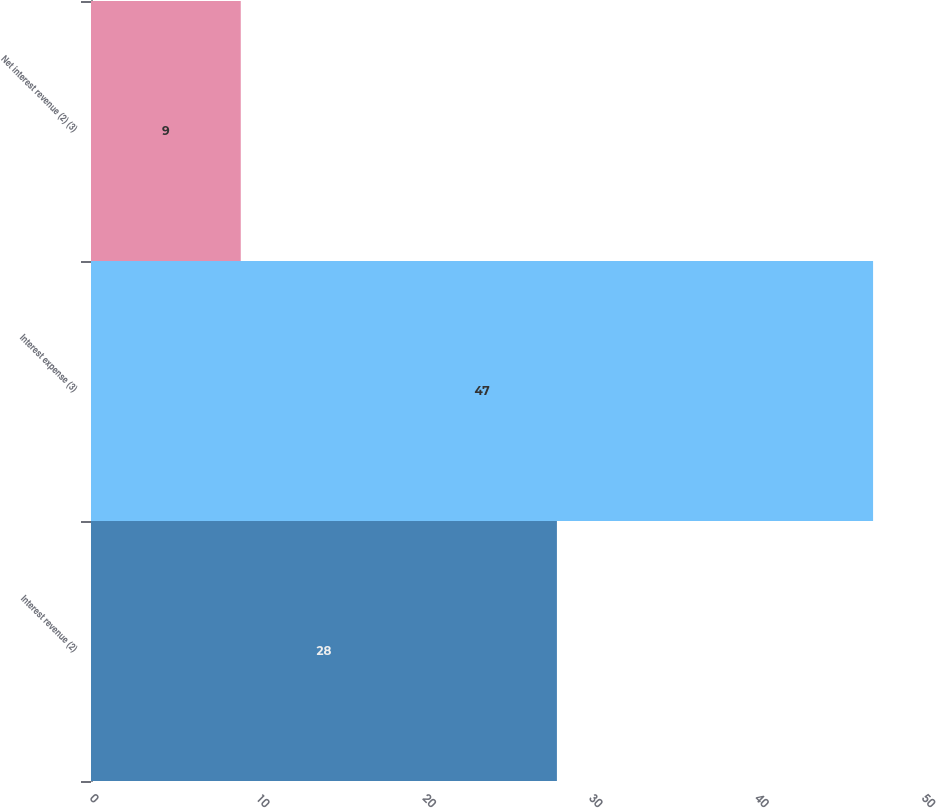Convert chart. <chart><loc_0><loc_0><loc_500><loc_500><bar_chart><fcel>Interest revenue (2)<fcel>Interest expense (3)<fcel>Net interest revenue (2) (3)<nl><fcel>28<fcel>47<fcel>9<nl></chart> 